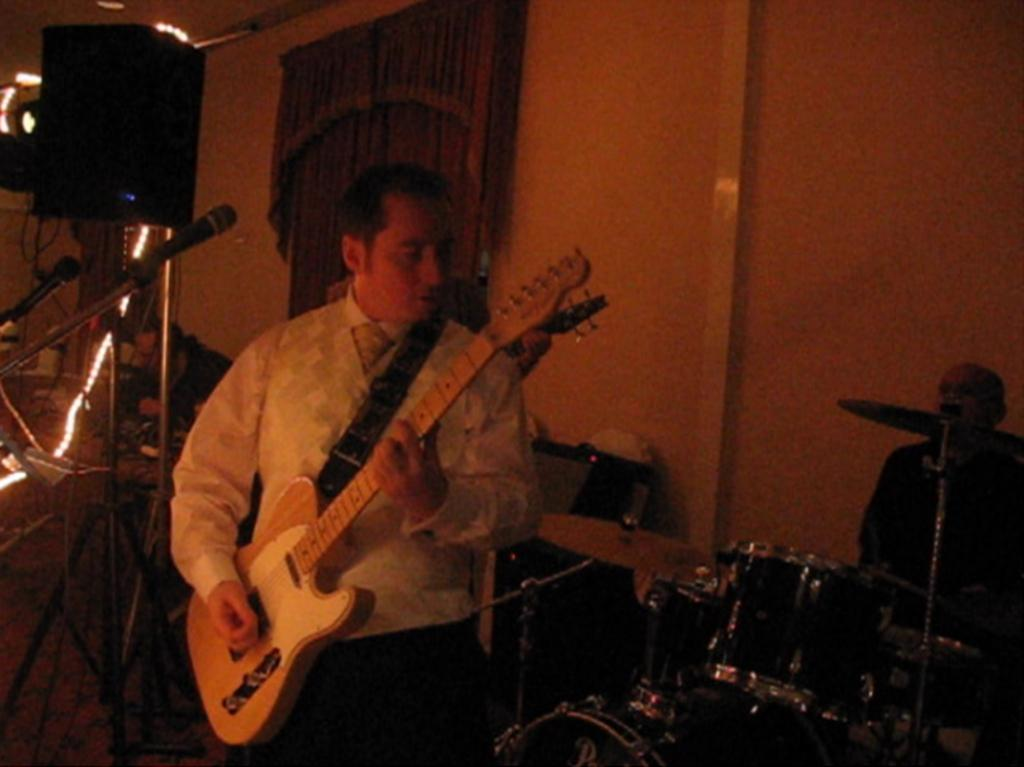What is the man in the image doing? The man is playing a guitar in the image. How is the guitar being held by the man? The guitar is in his hand. What other object related to music can be seen in the image? There is a microphone in the image. What type of crime is being committed in the image? There is no crime being committed in the image; it features a man playing a guitar. Can you describe the locket the man is wearing in the image? There is no locket visible in the image; the man is focused on playing the guitar. 